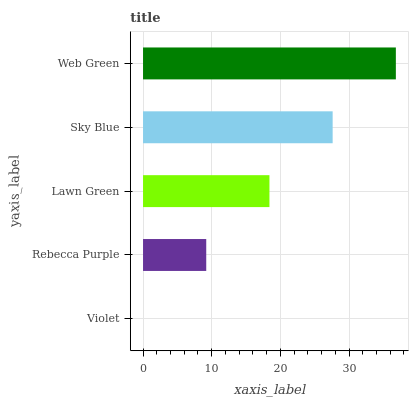Is Violet the minimum?
Answer yes or no. Yes. Is Web Green the maximum?
Answer yes or no. Yes. Is Rebecca Purple the minimum?
Answer yes or no. No. Is Rebecca Purple the maximum?
Answer yes or no. No. Is Rebecca Purple greater than Violet?
Answer yes or no. Yes. Is Violet less than Rebecca Purple?
Answer yes or no. Yes. Is Violet greater than Rebecca Purple?
Answer yes or no. No. Is Rebecca Purple less than Violet?
Answer yes or no. No. Is Lawn Green the high median?
Answer yes or no. Yes. Is Lawn Green the low median?
Answer yes or no. Yes. Is Sky Blue the high median?
Answer yes or no. No. Is Sky Blue the low median?
Answer yes or no. No. 